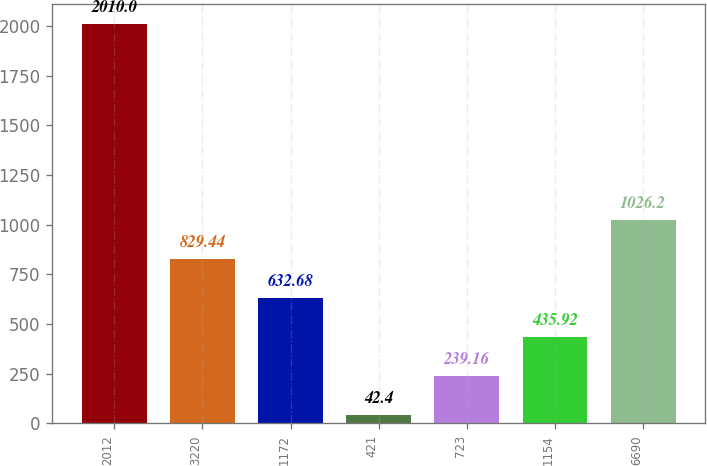Convert chart. <chart><loc_0><loc_0><loc_500><loc_500><bar_chart><fcel>2012<fcel>3220<fcel>1172<fcel>421<fcel>723<fcel>1154<fcel>6690<nl><fcel>2010<fcel>829.44<fcel>632.68<fcel>42.4<fcel>239.16<fcel>435.92<fcel>1026.2<nl></chart> 